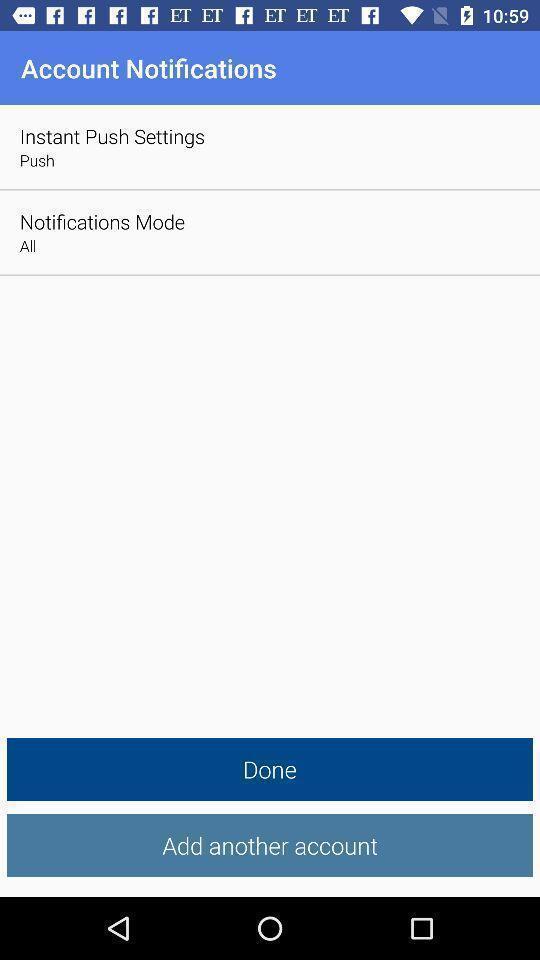Describe the key features of this screenshot. Page displaying an add account option. 